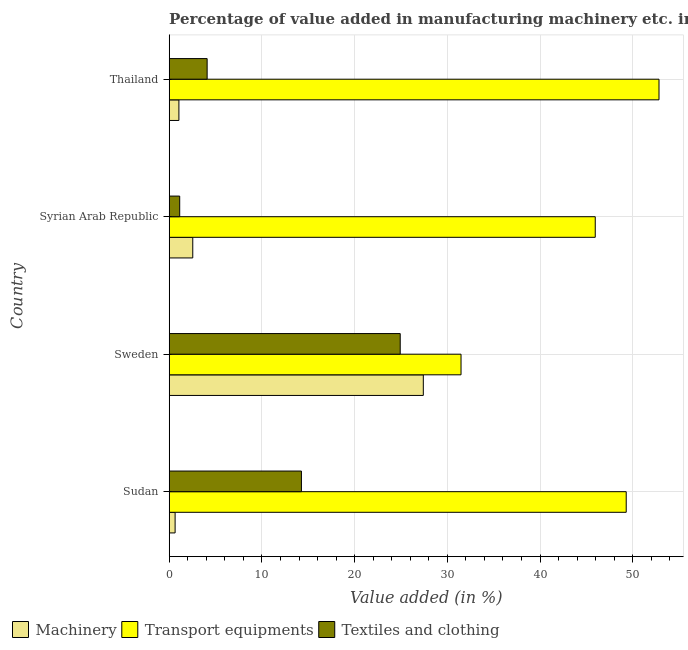Are the number of bars per tick equal to the number of legend labels?
Keep it short and to the point. Yes. Are the number of bars on each tick of the Y-axis equal?
Your answer should be compact. Yes. How many bars are there on the 4th tick from the top?
Ensure brevity in your answer.  3. What is the label of the 2nd group of bars from the top?
Provide a short and direct response. Syrian Arab Republic. What is the value added in manufacturing textile and clothing in Thailand?
Ensure brevity in your answer.  4.09. Across all countries, what is the maximum value added in manufacturing textile and clothing?
Your answer should be very brief. 24.92. Across all countries, what is the minimum value added in manufacturing transport equipments?
Give a very brief answer. 31.48. In which country was the value added in manufacturing machinery minimum?
Keep it short and to the point. Sudan. What is the total value added in manufacturing transport equipments in the graph?
Keep it short and to the point. 179.55. What is the difference between the value added in manufacturing machinery in Sudan and that in Syrian Arab Republic?
Offer a terse response. -1.9. What is the difference between the value added in manufacturing textile and clothing in Sudan and the value added in manufacturing transport equipments in Thailand?
Ensure brevity in your answer.  -38.57. What is the average value added in manufacturing transport equipments per country?
Offer a terse response. 44.89. What is the difference between the value added in manufacturing transport equipments and value added in manufacturing textile and clothing in Sudan?
Your response must be concise. 35.03. In how many countries, is the value added in manufacturing machinery greater than 46 %?
Your answer should be compact. 0. What is the ratio of the value added in manufacturing transport equipments in Syrian Arab Republic to that in Thailand?
Your response must be concise. 0.87. Is the difference between the value added in manufacturing textile and clothing in Sudan and Syrian Arab Republic greater than the difference between the value added in manufacturing machinery in Sudan and Syrian Arab Republic?
Keep it short and to the point. Yes. What is the difference between the highest and the second highest value added in manufacturing textile and clothing?
Give a very brief answer. 10.66. What is the difference between the highest and the lowest value added in manufacturing machinery?
Your answer should be very brief. 26.77. Is the sum of the value added in manufacturing machinery in Sweden and Thailand greater than the maximum value added in manufacturing textile and clothing across all countries?
Ensure brevity in your answer.  Yes. What does the 3rd bar from the top in Sudan represents?
Your response must be concise. Machinery. What does the 3rd bar from the bottom in Sweden represents?
Give a very brief answer. Textiles and clothing. Is it the case that in every country, the sum of the value added in manufacturing machinery and value added in manufacturing transport equipments is greater than the value added in manufacturing textile and clothing?
Ensure brevity in your answer.  Yes. Are all the bars in the graph horizontal?
Ensure brevity in your answer.  Yes. What is the difference between two consecutive major ticks on the X-axis?
Offer a very short reply. 10. Does the graph contain any zero values?
Offer a terse response. No. How are the legend labels stacked?
Your answer should be very brief. Horizontal. What is the title of the graph?
Make the answer very short. Percentage of value added in manufacturing machinery etc. in countries. Does "Negligence towards kids" appear as one of the legend labels in the graph?
Make the answer very short. No. What is the label or title of the X-axis?
Make the answer very short. Value added (in %). What is the label or title of the Y-axis?
Ensure brevity in your answer.  Country. What is the Value added (in %) in Machinery in Sudan?
Offer a very short reply. 0.64. What is the Value added (in %) in Transport equipments in Sudan?
Offer a very short reply. 49.29. What is the Value added (in %) in Textiles and clothing in Sudan?
Provide a short and direct response. 14.26. What is the Value added (in %) in Machinery in Sweden?
Offer a terse response. 27.41. What is the Value added (in %) of Transport equipments in Sweden?
Offer a very short reply. 31.48. What is the Value added (in %) of Textiles and clothing in Sweden?
Offer a terse response. 24.92. What is the Value added (in %) in Machinery in Syrian Arab Republic?
Provide a succinct answer. 2.54. What is the Value added (in %) in Transport equipments in Syrian Arab Republic?
Ensure brevity in your answer.  45.95. What is the Value added (in %) of Textiles and clothing in Syrian Arab Republic?
Keep it short and to the point. 1.13. What is the Value added (in %) in Machinery in Thailand?
Offer a very short reply. 1.05. What is the Value added (in %) of Transport equipments in Thailand?
Give a very brief answer. 52.83. What is the Value added (in %) in Textiles and clothing in Thailand?
Your answer should be very brief. 4.09. Across all countries, what is the maximum Value added (in %) of Machinery?
Provide a short and direct response. 27.41. Across all countries, what is the maximum Value added (in %) in Transport equipments?
Your response must be concise. 52.83. Across all countries, what is the maximum Value added (in %) in Textiles and clothing?
Provide a succinct answer. 24.92. Across all countries, what is the minimum Value added (in %) in Machinery?
Give a very brief answer. 0.64. Across all countries, what is the minimum Value added (in %) of Transport equipments?
Give a very brief answer. 31.48. Across all countries, what is the minimum Value added (in %) of Textiles and clothing?
Offer a terse response. 1.13. What is the total Value added (in %) of Machinery in the graph?
Provide a succinct answer. 31.63. What is the total Value added (in %) of Transport equipments in the graph?
Offer a terse response. 179.55. What is the total Value added (in %) in Textiles and clothing in the graph?
Your answer should be compact. 44.4. What is the difference between the Value added (in %) in Machinery in Sudan and that in Sweden?
Offer a very short reply. -26.77. What is the difference between the Value added (in %) in Transport equipments in Sudan and that in Sweden?
Give a very brief answer. 17.82. What is the difference between the Value added (in %) in Textiles and clothing in Sudan and that in Sweden?
Ensure brevity in your answer.  -10.66. What is the difference between the Value added (in %) of Machinery in Sudan and that in Syrian Arab Republic?
Keep it short and to the point. -1.9. What is the difference between the Value added (in %) in Transport equipments in Sudan and that in Syrian Arab Republic?
Offer a very short reply. 3.34. What is the difference between the Value added (in %) in Textiles and clothing in Sudan and that in Syrian Arab Republic?
Your answer should be compact. 13.13. What is the difference between the Value added (in %) of Machinery in Sudan and that in Thailand?
Your response must be concise. -0.41. What is the difference between the Value added (in %) in Transport equipments in Sudan and that in Thailand?
Keep it short and to the point. -3.54. What is the difference between the Value added (in %) of Textiles and clothing in Sudan and that in Thailand?
Provide a succinct answer. 10.17. What is the difference between the Value added (in %) in Machinery in Sweden and that in Syrian Arab Republic?
Keep it short and to the point. 24.87. What is the difference between the Value added (in %) of Transport equipments in Sweden and that in Syrian Arab Republic?
Offer a terse response. -14.48. What is the difference between the Value added (in %) in Textiles and clothing in Sweden and that in Syrian Arab Republic?
Give a very brief answer. 23.79. What is the difference between the Value added (in %) of Machinery in Sweden and that in Thailand?
Your answer should be very brief. 26.36. What is the difference between the Value added (in %) of Transport equipments in Sweden and that in Thailand?
Offer a very short reply. -21.35. What is the difference between the Value added (in %) of Textiles and clothing in Sweden and that in Thailand?
Your answer should be very brief. 20.83. What is the difference between the Value added (in %) in Machinery in Syrian Arab Republic and that in Thailand?
Keep it short and to the point. 1.49. What is the difference between the Value added (in %) in Transport equipments in Syrian Arab Republic and that in Thailand?
Your answer should be compact. -6.88. What is the difference between the Value added (in %) in Textiles and clothing in Syrian Arab Republic and that in Thailand?
Your response must be concise. -2.96. What is the difference between the Value added (in %) in Machinery in Sudan and the Value added (in %) in Transport equipments in Sweden?
Offer a terse response. -30.84. What is the difference between the Value added (in %) in Machinery in Sudan and the Value added (in %) in Textiles and clothing in Sweden?
Offer a terse response. -24.28. What is the difference between the Value added (in %) of Transport equipments in Sudan and the Value added (in %) of Textiles and clothing in Sweden?
Keep it short and to the point. 24.38. What is the difference between the Value added (in %) of Machinery in Sudan and the Value added (in %) of Transport equipments in Syrian Arab Republic?
Give a very brief answer. -45.32. What is the difference between the Value added (in %) of Machinery in Sudan and the Value added (in %) of Textiles and clothing in Syrian Arab Republic?
Give a very brief answer. -0.49. What is the difference between the Value added (in %) in Transport equipments in Sudan and the Value added (in %) in Textiles and clothing in Syrian Arab Republic?
Offer a terse response. 48.16. What is the difference between the Value added (in %) in Machinery in Sudan and the Value added (in %) in Transport equipments in Thailand?
Offer a terse response. -52.19. What is the difference between the Value added (in %) in Machinery in Sudan and the Value added (in %) in Textiles and clothing in Thailand?
Your answer should be compact. -3.45. What is the difference between the Value added (in %) of Transport equipments in Sudan and the Value added (in %) of Textiles and clothing in Thailand?
Keep it short and to the point. 45.2. What is the difference between the Value added (in %) in Machinery in Sweden and the Value added (in %) in Transport equipments in Syrian Arab Republic?
Keep it short and to the point. -18.54. What is the difference between the Value added (in %) of Machinery in Sweden and the Value added (in %) of Textiles and clothing in Syrian Arab Republic?
Your answer should be very brief. 26.28. What is the difference between the Value added (in %) in Transport equipments in Sweden and the Value added (in %) in Textiles and clothing in Syrian Arab Republic?
Your answer should be compact. 30.35. What is the difference between the Value added (in %) in Machinery in Sweden and the Value added (in %) in Transport equipments in Thailand?
Give a very brief answer. -25.42. What is the difference between the Value added (in %) in Machinery in Sweden and the Value added (in %) in Textiles and clothing in Thailand?
Your answer should be compact. 23.32. What is the difference between the Value added (in %) of Transport equipments in Sweden and the Value added (in %) of Textiles and clothing in Thailand?
Your response must be concise. 27.39. What is the difference between the Value added (in %) in Machinery in Syrian Arab Republic and the Value added (in %) in Transport equipments in Thailand?
Provide a succinct answer. -50.29. What is the difference between the Value added (in %) of Machinery in Syrian Arab Republic and the Value added (in %) of Textiles and clothing in Thailand?
Keep it short and to the point. -1.55. What is the difference between the Value added (in %) in Transport equipments in Syrian Arab Republic and the Value added (in %) in Textiles and clothing in Thailand?
Your answer should be compact. 41.86. What is the average Value added (in %) of Machinery per country?
Make the answer very short. 7.91. What is the average Value added (in %) of Transport equipments per country?
Give a very brief answer. 44.89. What is the average Value added (in %) of Textiles and clothing per country?
Your answer should be very brief. 11.1. What is the difference between the Value added (in %) of Machinery and Value added (in %) of Transport equipments in Sudan?
Offer a very short reply. -48.66. What is the difference between the Value added (in %) in Machinery and Value added (in %) in Textiles and clothing in Sudan?
Provide a succinct answer. -13.62. What is the difference between the Value added (in %) in Transport equipments and Value added (in %) in Textiles and clothing in Sudan?
Your response must be concise. 35.03. What is the difference between the Value added (in %) in Machinery and Value added (in %) in Transport equipments in Sweden?
Offer a very short reply. -4.07. What is the difference between the Value added (in %) of Machinery and Value added (in %) of Textiles and clothing in Sweden?
Offer a terse response. 2.49. What is the difference between the Value added (in %) in Transport equipments and Value added (in %) in Textiles and clothing in Sweden?
Keep it short and to the point. 6.56. What is the difference between the Value added (in %) of Machinery and Value added (in %) of Transport equipments in Syrian Arab Republic?
Your answer should be compact. -43.41. What is the difference between the Value added (in %) of Machinery and Value added (in %) of Textiles and clothing in Syrian Arab Republic?
Your response must be concise. 1.41. What is the difference between the Value added (in %) in Transport equipments and Value added (in %) in Textiles and clothing in Syrian Arab Republic?
Provide a short and direct response. 44.82. What is the difference between the Value added (in %) of Machinery and Value added (in %) of Transport equipments in Thailand?
Provide a succinct answer. -51.78. What is the difference between the Value added (in %) in Machinery and Value added (in %) in Textiles and clothing in Thailand?
Offer a very short reply. -3.04. What is the difference between the Value added (in %) in Transport equipments and Value added (in %) in Textiles and clothing in Thailand?
Your response must be concise. 48.74. What is the ratio of the Value added (in %) in Machinery in Sudan to that in Sweden?
Offer a very short reply. 0.02. What is the ratio of the Value added (in %) of Transport equipments in Sudan to that in Sweden?
Make the answer very short. 1.57. What is the ratio of the Value added (in %) in Textiles and clothing in Sudan to that in Sweden?
Make the answer very short. 0.57. What is the ratio of the Value added (in %) in Machinery in Sudan to that in Syrian Arab Republic?
Your answer should be very brief. 0.25. What is the ratio of the Value added (in %) in Transport equipments in Sudan to that in Syrian Arab Republic?
Keep it short and to the point. 1.07. What is the ratio of the Value added (in %) in Textiles and clothing in Sudan to that in Syrian Arab Republic?
Provide a short and direct response. 12.6. What is the ratio of the Value added (in %) of Machinery in Sudan to that in Thailand?
Provide a short and direct response. 0.61. What is the ratio of the Value added (in %) in Transport equipments in Sudan to that in Thailand?
Ensure brevity in your answer.  0.93. What is the ratio of the Value added (in %) of Textiles and clothing in Sudan to that in Thailand?
Keep it short and to the point. 3.49. What is the ratio of the Value added (in %) of Machinery in Sweden to that in Syrian Arab Republic?
Offer a terse response. 10.79. What is the ratio of the Value added (in %) of Transport equipments in Sweden to that in Syrian Arab Republic?
Make the answer very short. 0.69. What is the ratio of the Value added (in %) in Textiles and clothing in Sweden to that in Syrian Arab Republic?
Offer a terse response. 22.02. What is the ratio of the Value added (in %) in Machinery in Sweden to that in Thailand?
Offer a terse response. 26.18. What is the ratio of the Value added (in %) in Transport equipments in Sweden to that in Thailand?
Keep it short and to the point. 0.6. What is the ratio of the Value added (in %) in Textiles and clothing in Sweden to that in Thailand?
Provide a short and direct response. 6.09. What is the ratio of the Value added (in %) in Machinery in Syrian Arab Republic to that in Thailand?
Make the answer very short. 2.43. What is the ratio of the Value added (in %) of Transport equipments in Syrian Arab Republic to that in Thailand?
Provide a succinct answer. 0.87. What is the ratio of the Value added (in %) in Textiles and clothing in Syrian Arab Republic to that in Thailand?
Your answer should be very brief. 0.28. What is the difference between the highest and the second highest Value added (in %) in Machinery?
Your answer should be very brief. 24.87. What is the difference between the highest and the second highest Value added (in %) in Transport equipments?
Ensure brevity in your answer.  3.54. What is the difference between the highest and the second highest Value added (in %) of Textiles and clothing?
Provide a short and direct response. 10.66. What is the difference between the highest and the lowest Value added (in %) in Machinery?
Offer a terse response. 26.77. What is the difference between the highest and the lowest Value added (in %) of Transport equipments?
Keep it short and to the point. 21.35. What is the difference between the highest and the lowest Value added (in %) in Textiles and clothing?
Your answer should be very brief. 23.79. 